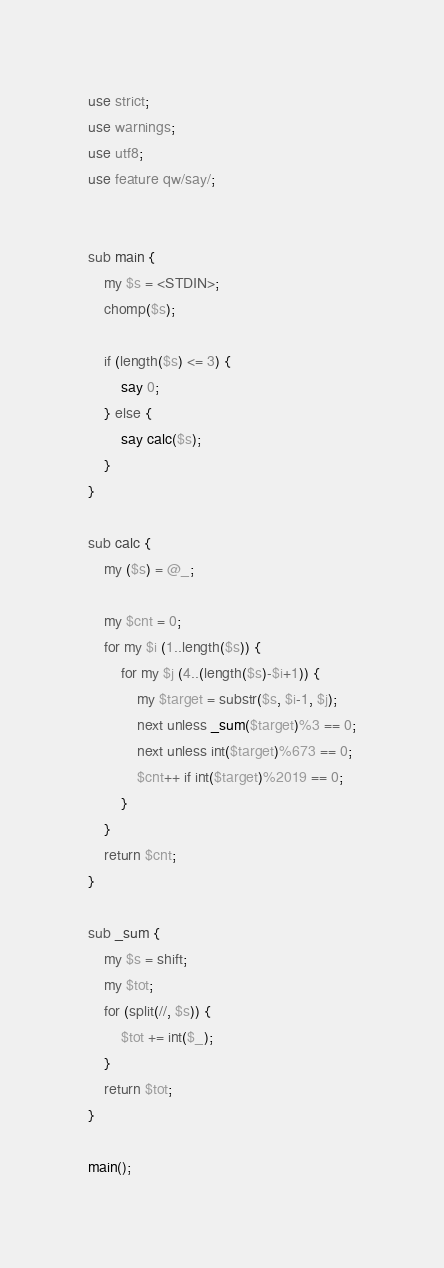Convert code to text. <code><loc_0><loc_0><loc_500><loc_500><_Perl_>use strict;
use warnings;
use utf8;
use feature qw/say/;


sub main {
    my $s = <STDIN>;
    chomp($s);
    
    if (length($s) <= 3) {
        say 0;
    } else {
        say calc($s);
    }
}

sub calc {
    my ($s) = @_;

    my $cnt = 0;
    for my $i (1..length($s)) {
        for my $j (4..(length($s)-$i+1)) {
            my $target = substr($s, $i-1, $j);
            next unless _sum($target)%3 == 0;
            next unless int($target)%673 == 0;
            $cnt++ if int($target)%2019 == 0;
        }       
    }
    return $cnt;
}

sub _sum {
    my $s = shift;
    my $tot;
    for (split(//, $s)) {
        $tot += int($_);
    }
    return $tot;
}

main();</code> 